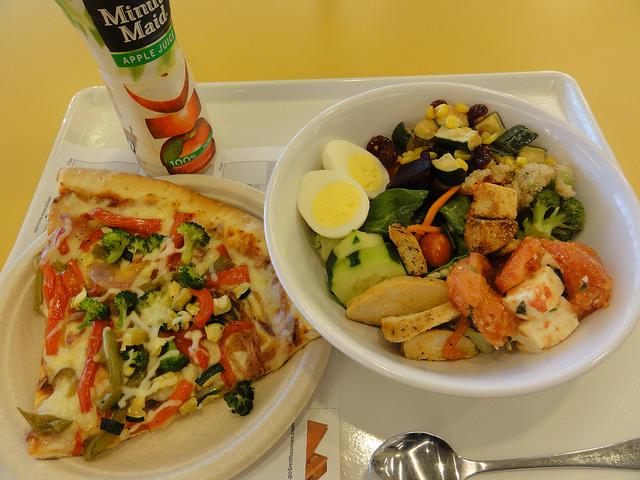What style of eggs are in the bowl?
Write a very short answer. Boiled. Is there apple juice on the tray?
Concise answer only. Yes. What brand of juice is on the tray?
Give a very brief answer. Minute maid. 